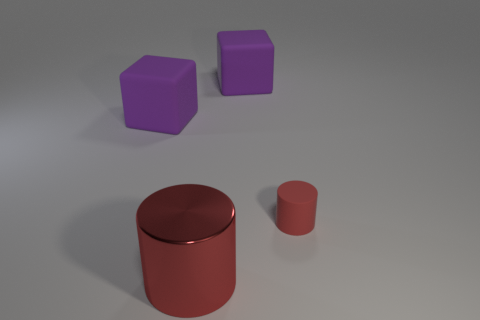Add 2 red matte cylinders. How many objects exist? 6 Add 3 large purple objects. How many large purple objects are left? 5 Add 3 big red matte cylinders. How many big red matte cylinders exist? 3 Subtract 0 cyan spheres. How many objects are left? 4 Subtract all red shiny cylinders. Subtract all matte objects. How many objects are left? 0 